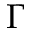Convert formula to latex. <formula><loc_0><loc_0><loc_500><loc_500>\Gamma</formula> 